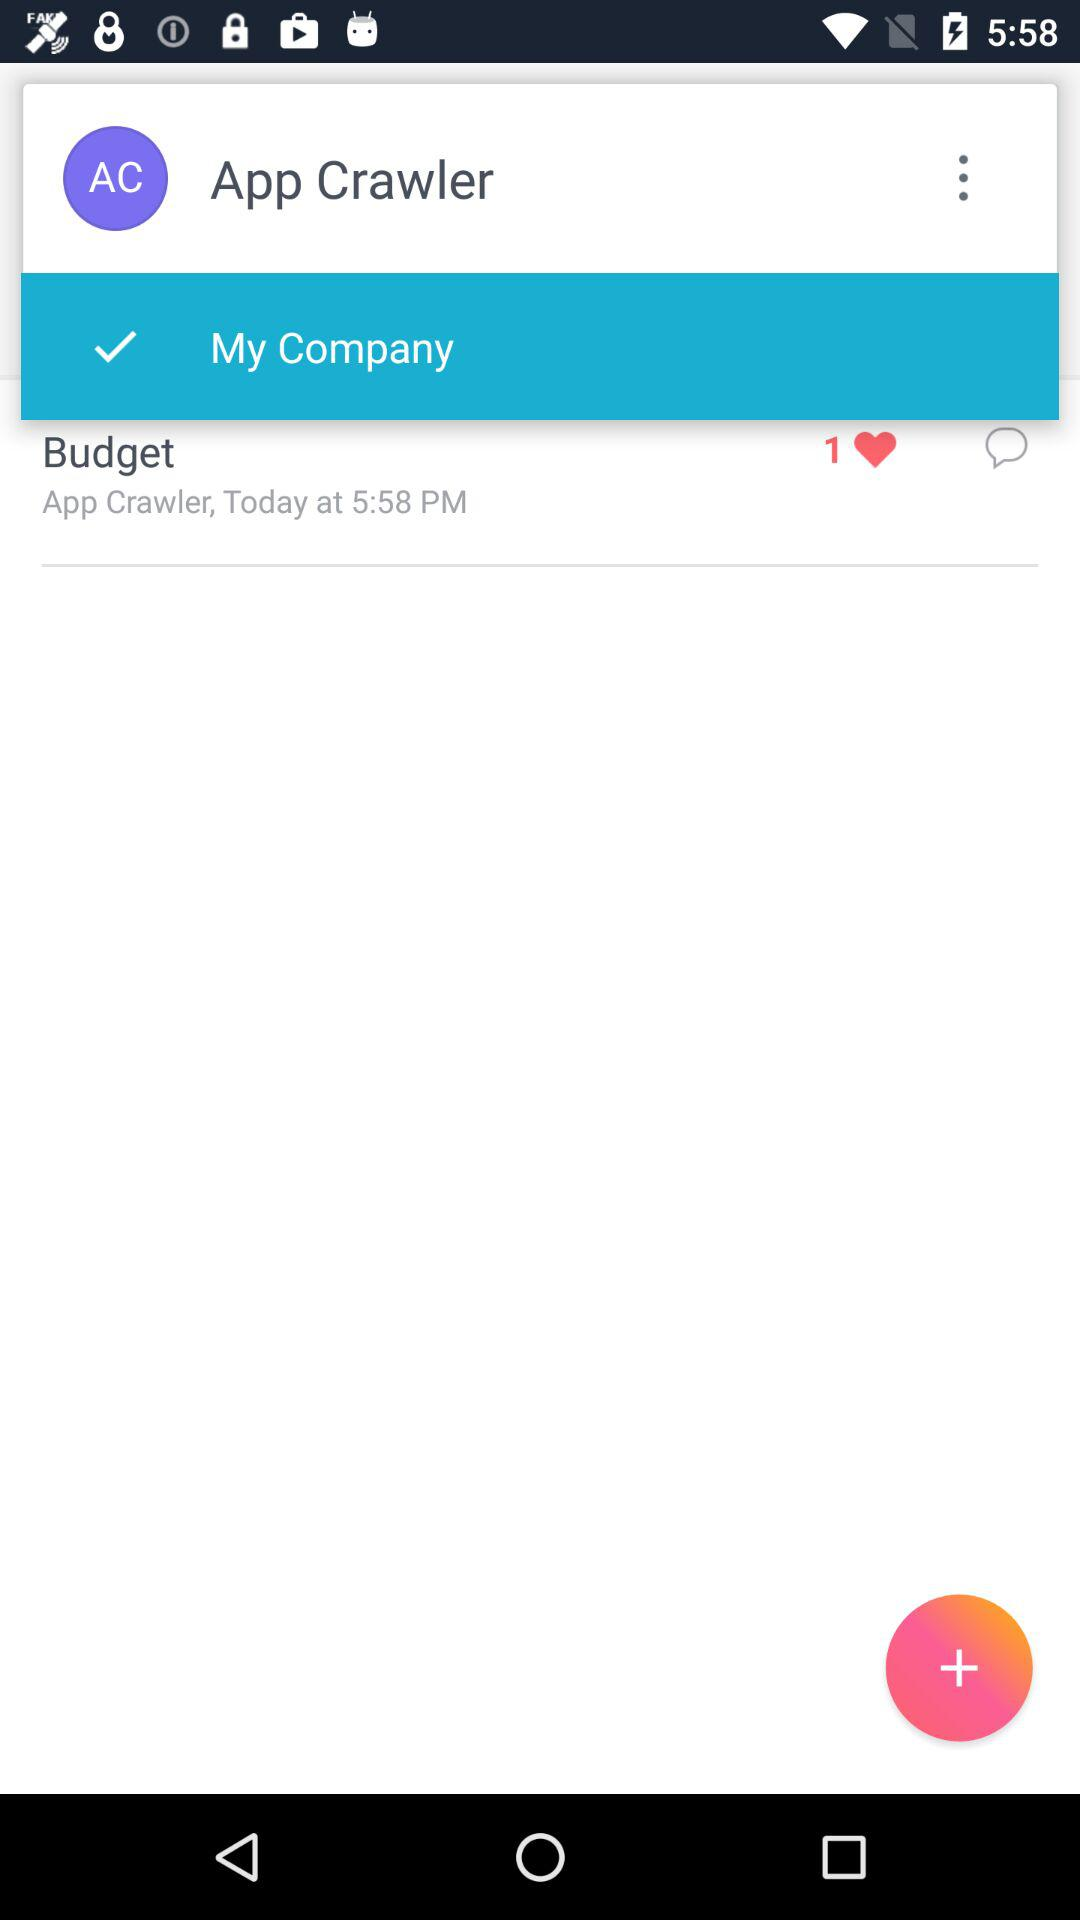How many times was "Budget" reposted?
When the provided information is insufficient, respond with <no answer>. <no answer> 